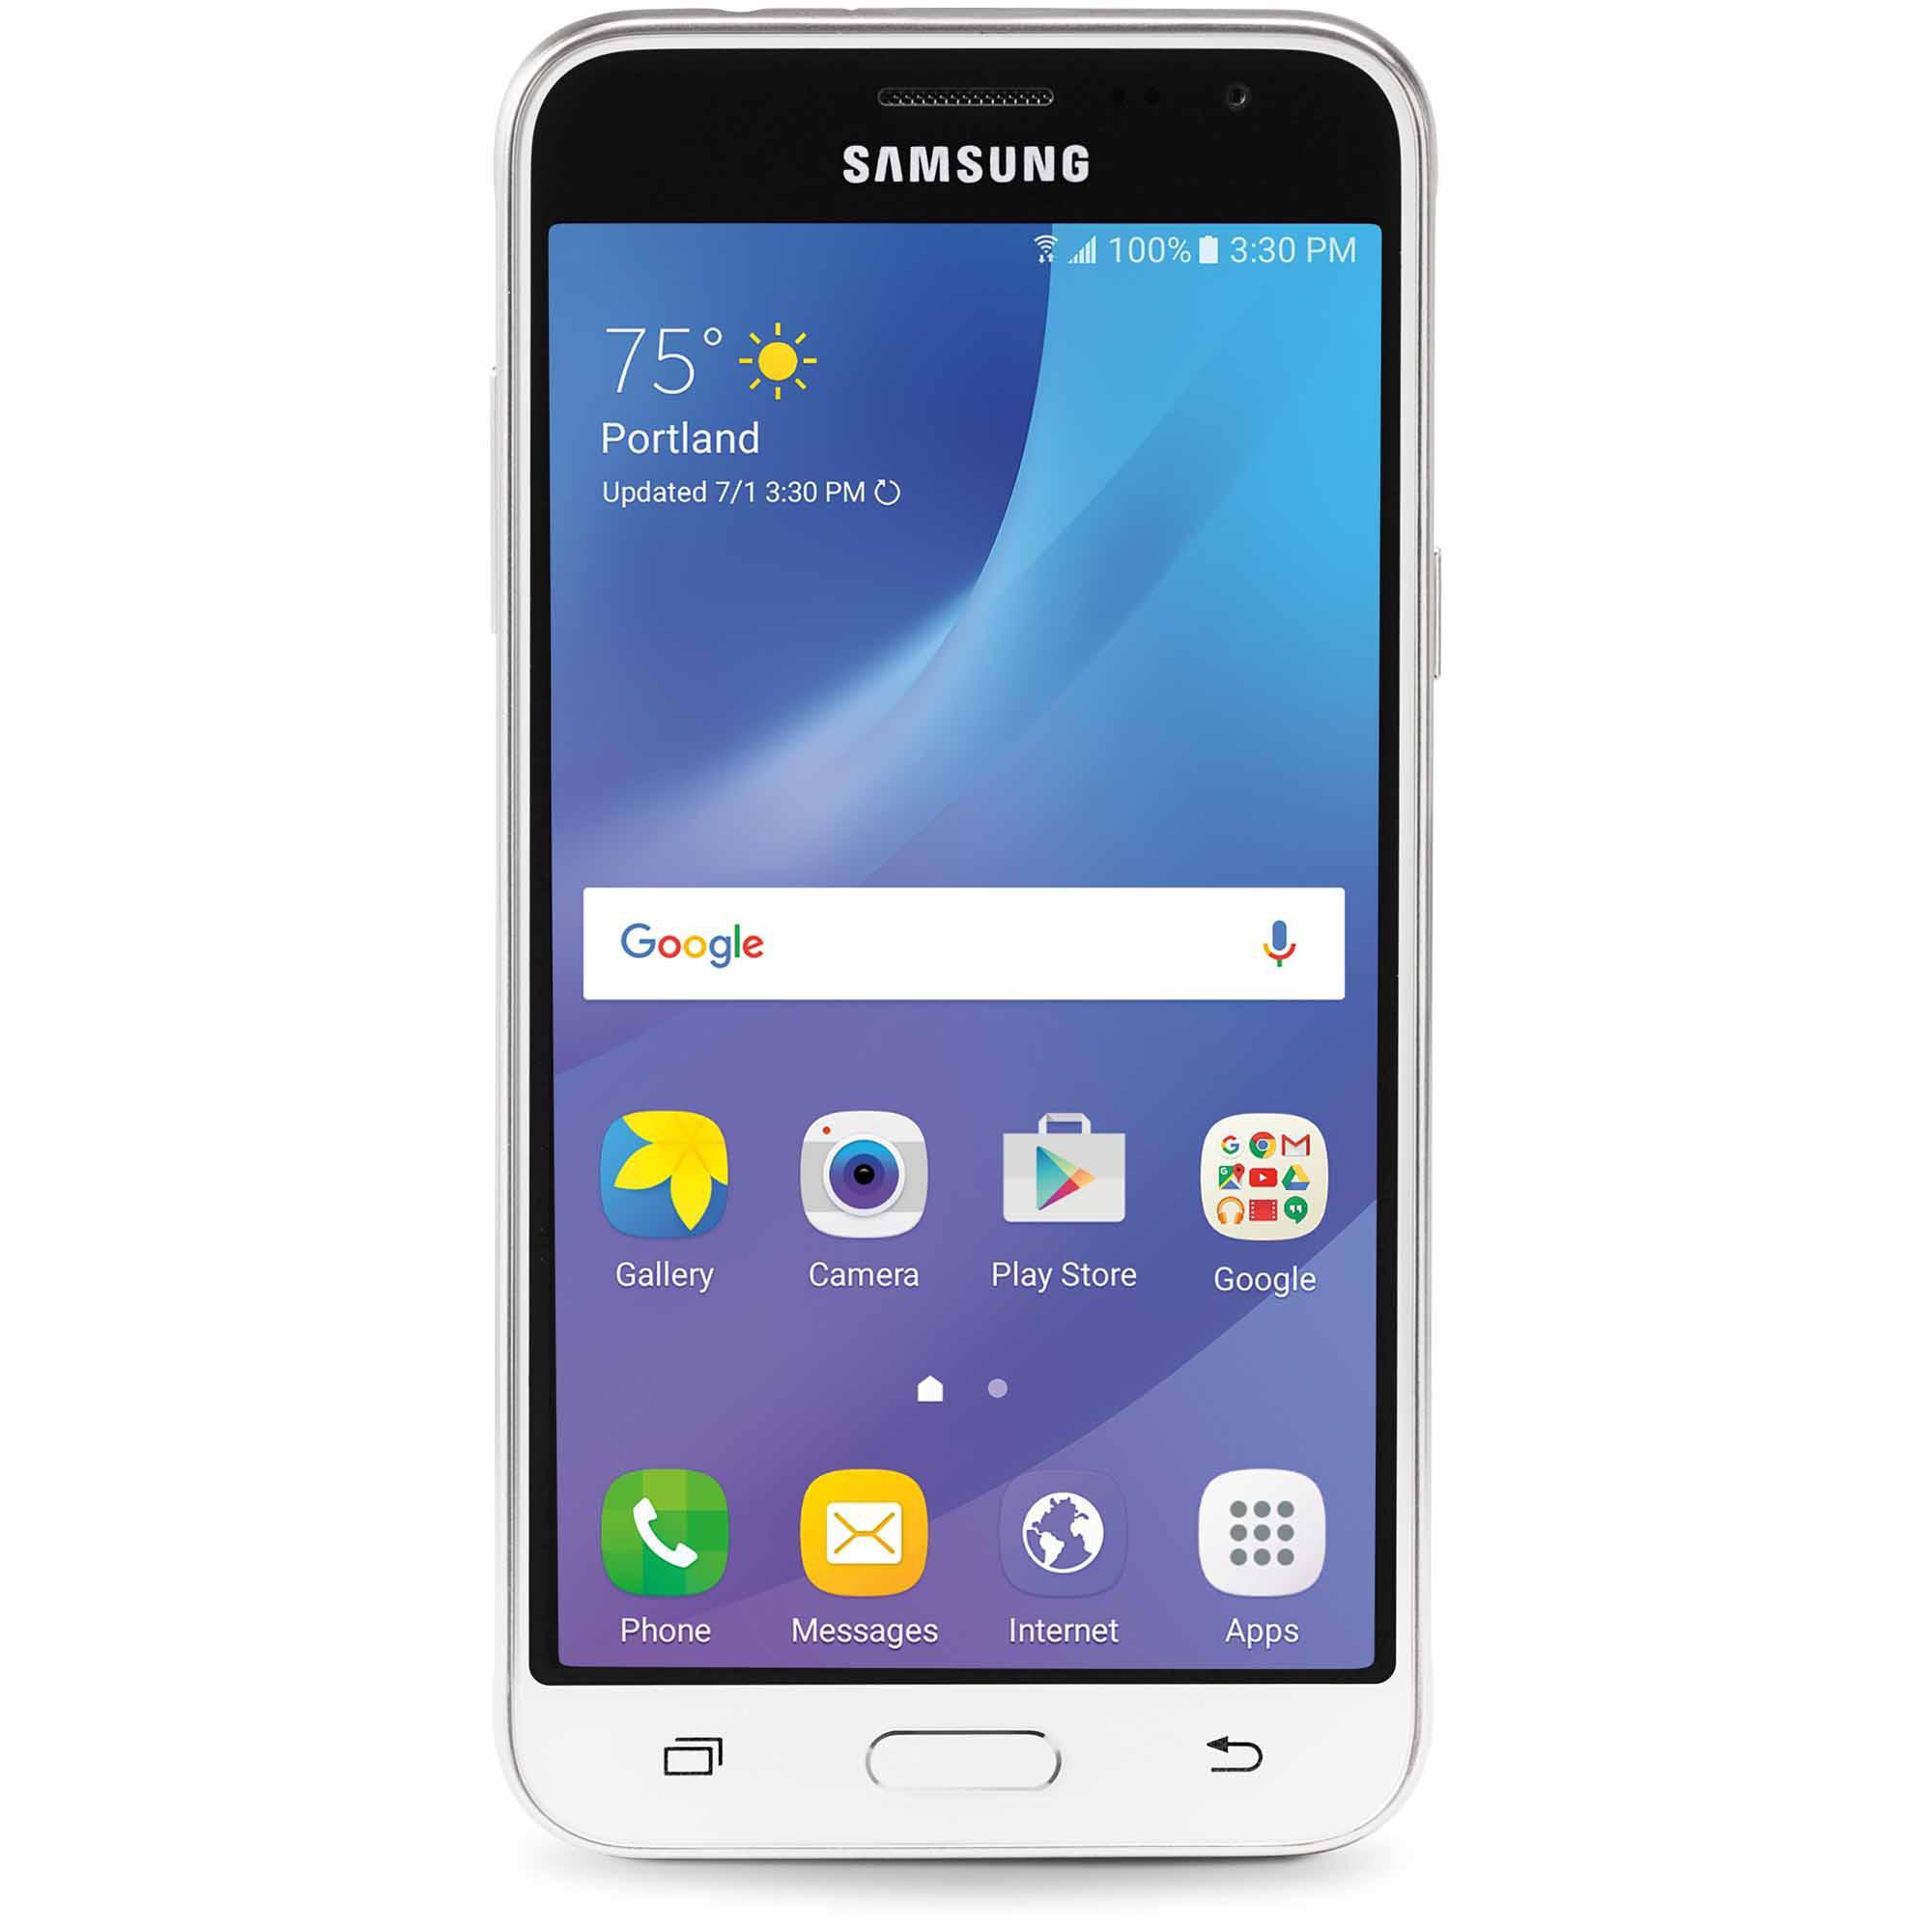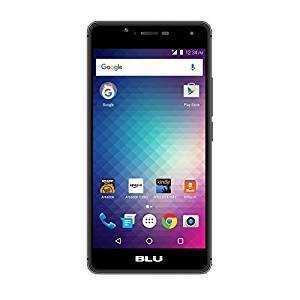The first image is the image on the left, the second image is the image on the right. Evaluate the accuracy of this statement regarding the images: "The cellphone in each image shows the Google search bar on it's home page.". Is it true? Answer yes or no. Yes. 